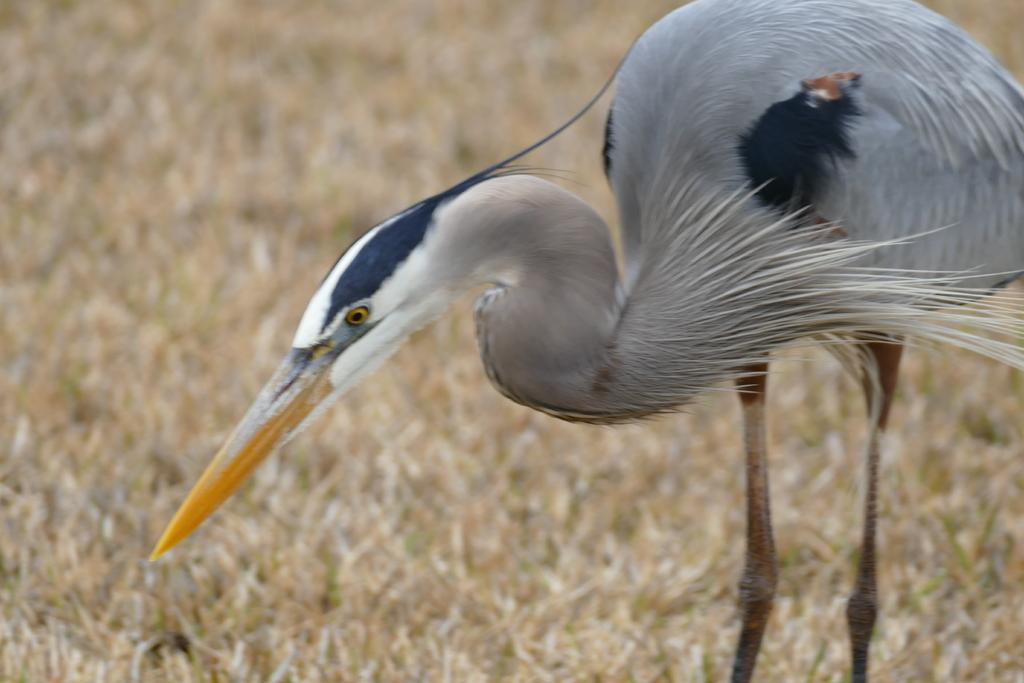Could you give a brief overview of what you see in this image? In this image I can see a bird in white and gray color. Background I can see dried grass. 